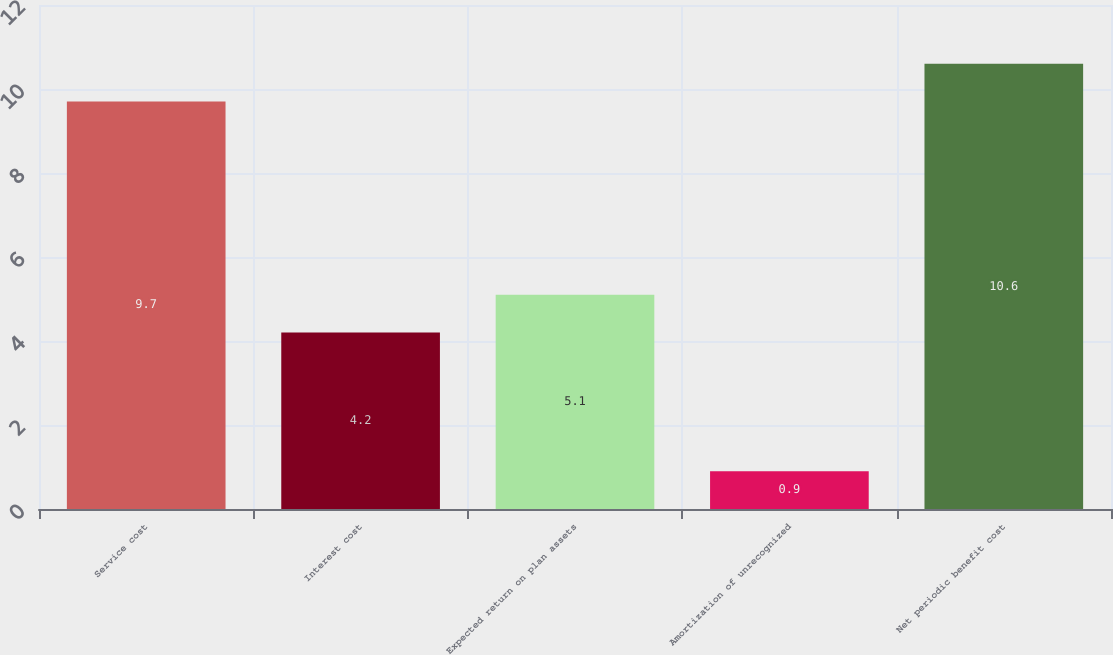Convert chart to OTSL. <chart><loc_0><loc_0><loc_500><loc_500><bar_chart><fcel>Service cost<fcel>Interest cost<fcel>Expected return on plan assets<fcel>Amortization of unrecognized<fcel>Net periodic benefit cost<nl><fcel>9.7<fcel>4.2<fcel>5.1<fcel>0.9<fcel>10.6<nl></chart> 